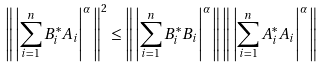Convert formula to latex. <formula><loc_0><loc_0><loc_500><loc_500>\left \| \, \left | \sum _ { i = 1 } ^ { n } B ^ { * } _ { i } A _ { i } \right | ^ { \alpha } \, \right \| ^ { 2 } \leq \left \| \, \left | \sum _ { i = 1 } ^ { n } B ^ { * } _ { i } B _ { i } \right | ^ { \alpha } \, \right \| \left \| \, \left | \sum _ { i = 1 } ^ { n } A ^ { * } _ { i } A _ { i } \right | ^ { \alpha } \, \right \|</formula> 